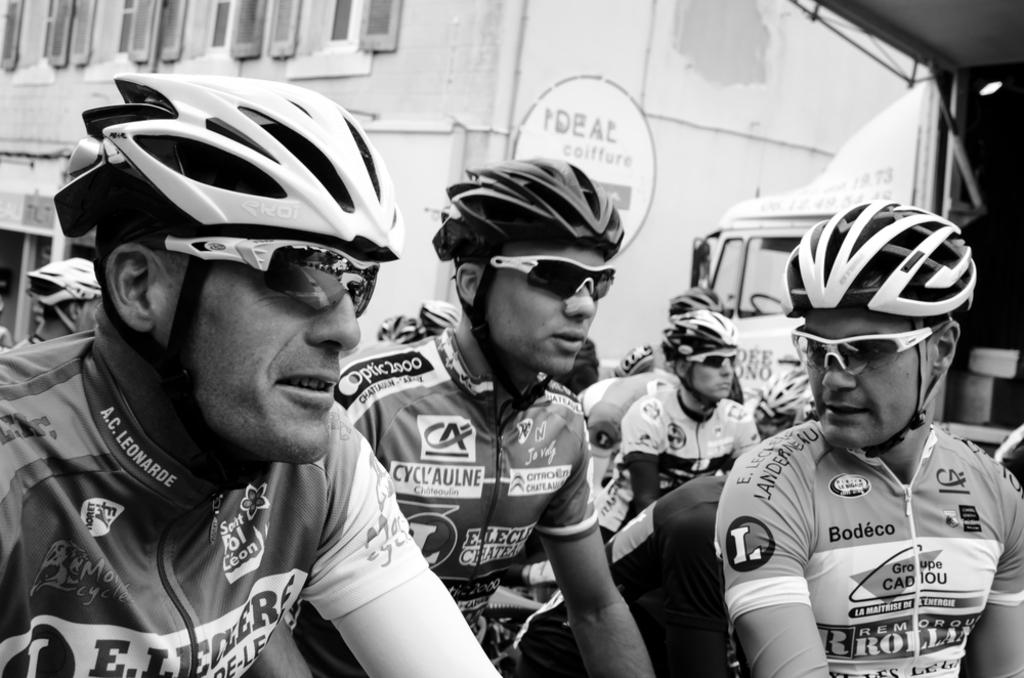What type of picture is in the image? The image contains a black and white picture. Who or what can be seen in the picture? There are people in the picture. What are the people wearing in the image? The people are wearing clothes, goggles, and helmets. What else is present in the image besides the people? There is a vehicle and a building in the image. Can you describe the building in the image? The building has windows. What type of cherry is hanging from the building in the image? There is no cherry present in the image; the building has windows, but no cherry is mentioned or visible. Can you hear the people in the image talking to each other? The image is a still picture, so we cannot hear any sounds or conversations taking place. 